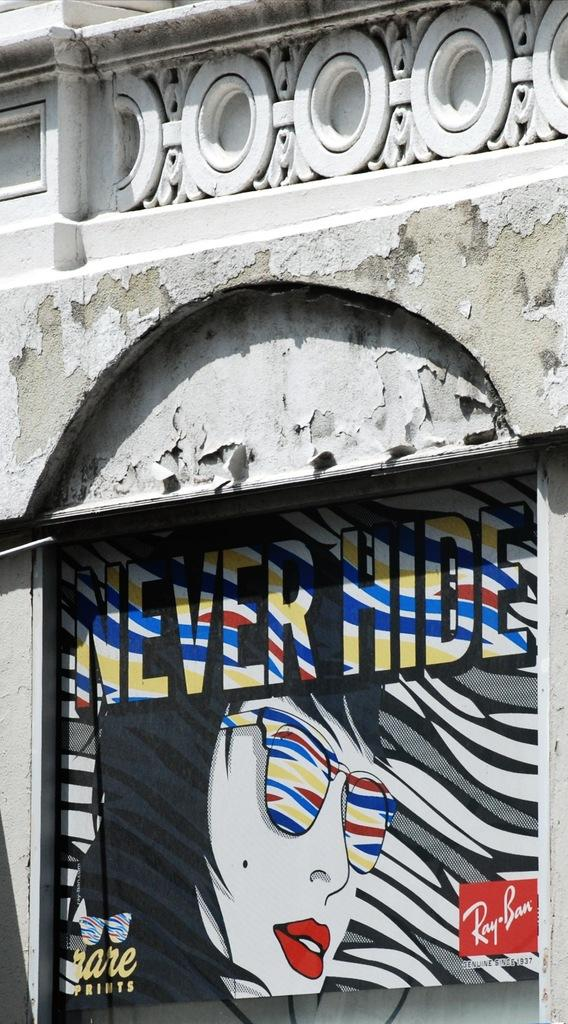What is present on the wall in the image? There is a poster on the wall in the image. Can you see a person interacting with the poster in the image? There is no person present in the image, and therefore no interaction with the poster can be observed. 